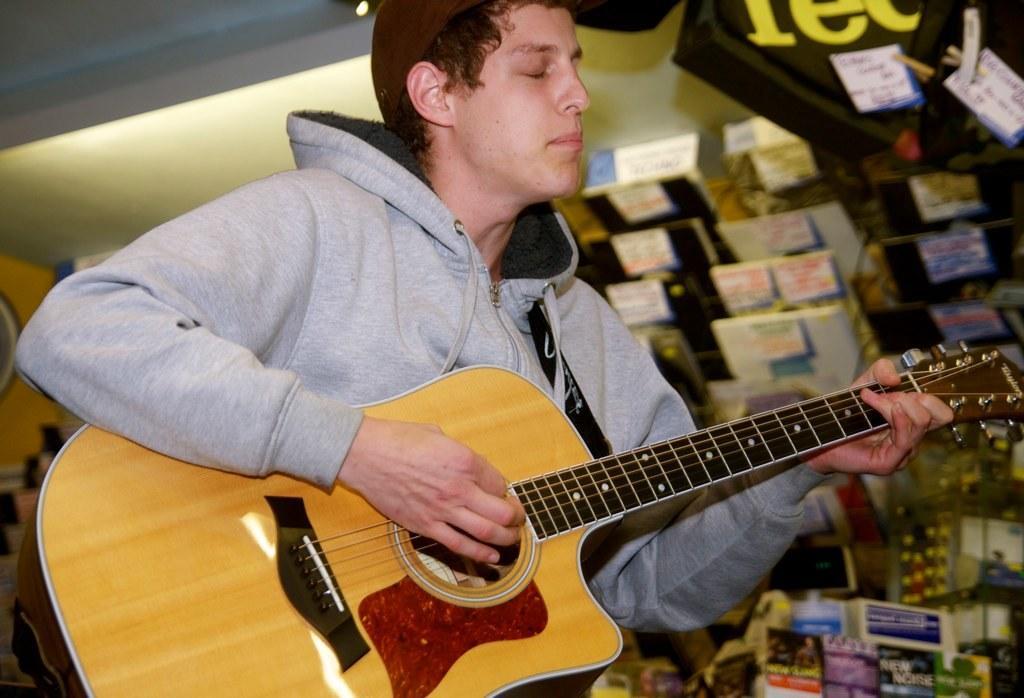Can you describe this image briefly? In this picture we can see a person is standing and playing the guitar, and at back here are the books. 